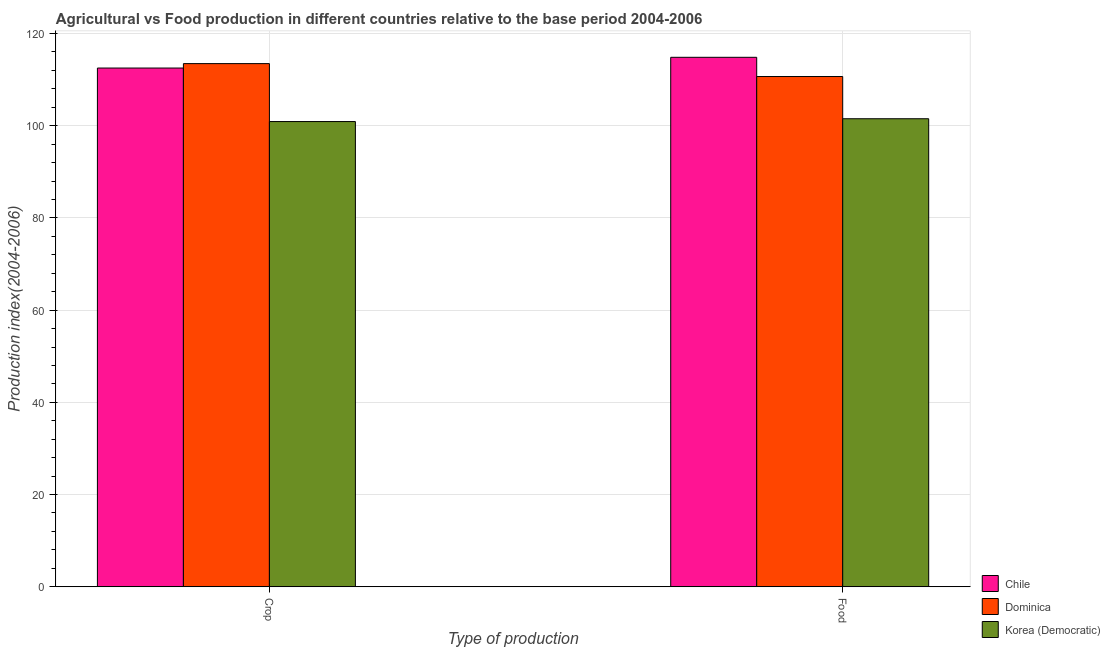How many different coloured bars are there?
Your response must be concise. 3. How many groups of bars are there?
Give a very brief answer. 2. Are the number of bars on each tick of the X-axis equal?
Ensure brevity in your answer.  Yes. How many bars are there on the 2nd tick from the left?
Offer a very short reply. 3. What is the label of the 1st group of bars from the left?
Your answer should be very brief. Crop. What is the food production index in Korea (Democratic)?
Ensure brevity in your answer.  101.52. Across all countries, what is the maximum food production index?
Your answer should be very brief. 114.85. Across all countries, what is the minimum food production index?
Offer a terse response. 101.52. In which country was the food production index maximum?
Keep it short and to the point. Chile. In which country was the food production index minimum?
Your answer should be compact. Korea (Democratic). What is the total food production index in the graph?
Provide a succinct answer. 327.05. What is the difference between the crop production index in Chile and that in Korea (Democratic)?
Your answer should be very brief. 11.61. What is the difference between the crop production index in Korea (Democratic) and the food production index in Chile?
Give a very brief answer. -13.94. What is the average food production index per country?
Your response must be concise. 109.02. What is the difference between the crop production index and food production index in Dominica?
Keep it short and to the point. 2.8. What is the ratio of the food production index in Dominica to that in Chile?
Give a very brief answer. 0.96. Is the crop production index in Chile less than that in Dominica?
Your response must be concise. Yes. What does the 3rd bar from the left in Crop represents?
Your answer should be very brief. Korea (Democratic). How many bars are there?
Keep it short and to the point. 6. How many countries are there in the graph?
Ensure brevity in your answer.  3. Are the values on the major ticks of Y-axis written in scientific E-notation?
Offer a very short reply. No. Does the graph contain grids?
Provide a short and direct response. Yes. How many legend labels are there?
Provide a succinct answer. 3. How are the legend labels stacked?
Offer a terse response. Vertical. What is the title of the graph?
Provide a succinct answer. Agricultural vs Food production in different countries relative to the base period 2004-2006. What is the label or title of the X-axis?
Offer a very short reply. Type of production. What is the label or title of the Y-axis?
Your answer should be very brief. Production index(2004-2006). What is the Production index(2004-2006) of Chile in Crop?
Make the answer very short. 112.52. What is the Production index(2004-2006) in Dominica in Crop?
Provide a succinct answer. 113.48. What is the Production index(2004-2006) in Korea (Democratic) in Crop?
Provide a succinct answer. 100.91. What is the Production index(2004-2006) of Chile in Food?
Make the answer very short. 114.85. What is the Production index(2004-2006) of Dominica in Food?
Provide a succinct answer. 110.68. What is the Production index(2004-2006) of Korea (Democratic) in Food?
Your response must be concise. 101.52. Across all Type of production, what is the maximum Production index(2004-2006) in Chile?
Your answer should be compact. 114.85. Across all Type of production, what is the maximum Production index(2004-2006) of Dominica?
Keep it short and to the point. 113.48. Across all Type of production, what is the maximum Production index(2004-2006) in Korea (Democratic)?
Make the answer very short. 101.52. Across all Type of production, what is the minimum Production index(2004-2006) in Chile?
Keep it short and to the point. 112.52. Across all Type of production, what is the minimum Production index(2004-2006) in Dominica?
Give a very brief answer. 110.68. Across all Type of production, what is the minimum Production index(2004-2006) of Korea (Democratic)?
Your answer should be very brief. 100.91. What is the total Production index(2004-2006) in Chile in the graph?
Offer a very short reply. 227.37. What is the total Production index(2004-2006) in Dominica in the graph?
Your response must be concise. 224.16. What is the total Production index(2004-2006) of Korea (Democratic) in the graph?
Your response must be concise. 202.43. What is the difference between the Production index(2004-2006) in Chile in Crop and that in Food?
Your answer should be compact. -2.33. What is the difference between the Production index(2004-2006) of Dominica in Crop and that in Food?
Your response must be concise. 2.8. What is the difference between the Production index(2004-2006) in Korea (Democratic) in Crop and that in Food?
Your answer should be compact. -0.61. What is the difference between the Production index(2004-2006) in Chile in Crop and the Production index(2004-2006) in Dominica in Food?
Ensure brevity in your answer.  1.84. What is the difference between the Production index(2004-2006) of Dominica in Crop and the Production index(2004-2006) of Korea (Democratic) in Food?
Your answer should be compact. 11.96. What is the average Production index(2004-2006) of Chile per Type of production?
Your answer should be very brief. 113.69. What is the average Production index(2004-2006) of Dominica per Type of production?
Your response must be concise. 112.08. What is the average Production index(2004-2006) of Korea (Democratic) per Type of production?
Offer a very short reply. 101.22. What is the difference between the Production index(2004-2006) in Chile and Production index(2004-2006) in Dominica in Crop?
Keep it short and to the point. -0.96. What is the difference between the Production index(2004-2006) of Chile and Production index(2004-2006) of Korea (Democratic) in Crop?
Offer a terse response. 11.61. What is the difference between the Production index(2004-2006) in Dominica and Production index(2004-2006) in Korea (Democratic) in Crop?
Keep it short and to the point. 12.57. What is the difference between the Production index(2004-2006) of Chile and Production index(2004-2006) of Dominica in Food?
Your response must be concise. 4.17. What is the difference between the Production index(2004-2006) of Chile and Production index(2004-2006) of Korea (Democratic) in Food?
Offer a terse response. 13.33. What is the difference between the Production index(2004-2006) in Dominica and Production index(2004-2006) in Korea (Democratic) in Food?
Make the answer very short. 9.16. What is the ratio of the Production index(2004-2006) in Chile in Crop to that in Food?
Make the answer very short. 0.98. What is the ratio of the Production index(2004-2006) of Dominica in Crop to that in Food?
Offer a terse response. 1.03. What is the difference between the highest and the second highest Production index(2004-2006) in Chile?
Your response must be concise. 2.33. What is the difference between the highest and the second highest Production index(2004-2006) of Korea (Democratic)?
Your response must be concise. 0.61. What is the difference between the highest and the lowest Production index(2004-2006) of Chile?
Offer a terse response. 2.33. What is the difference between the highest and the lowest Production index(2004-2006) of Korea (Democratic)?
Offer a very short reply. 0.61. 